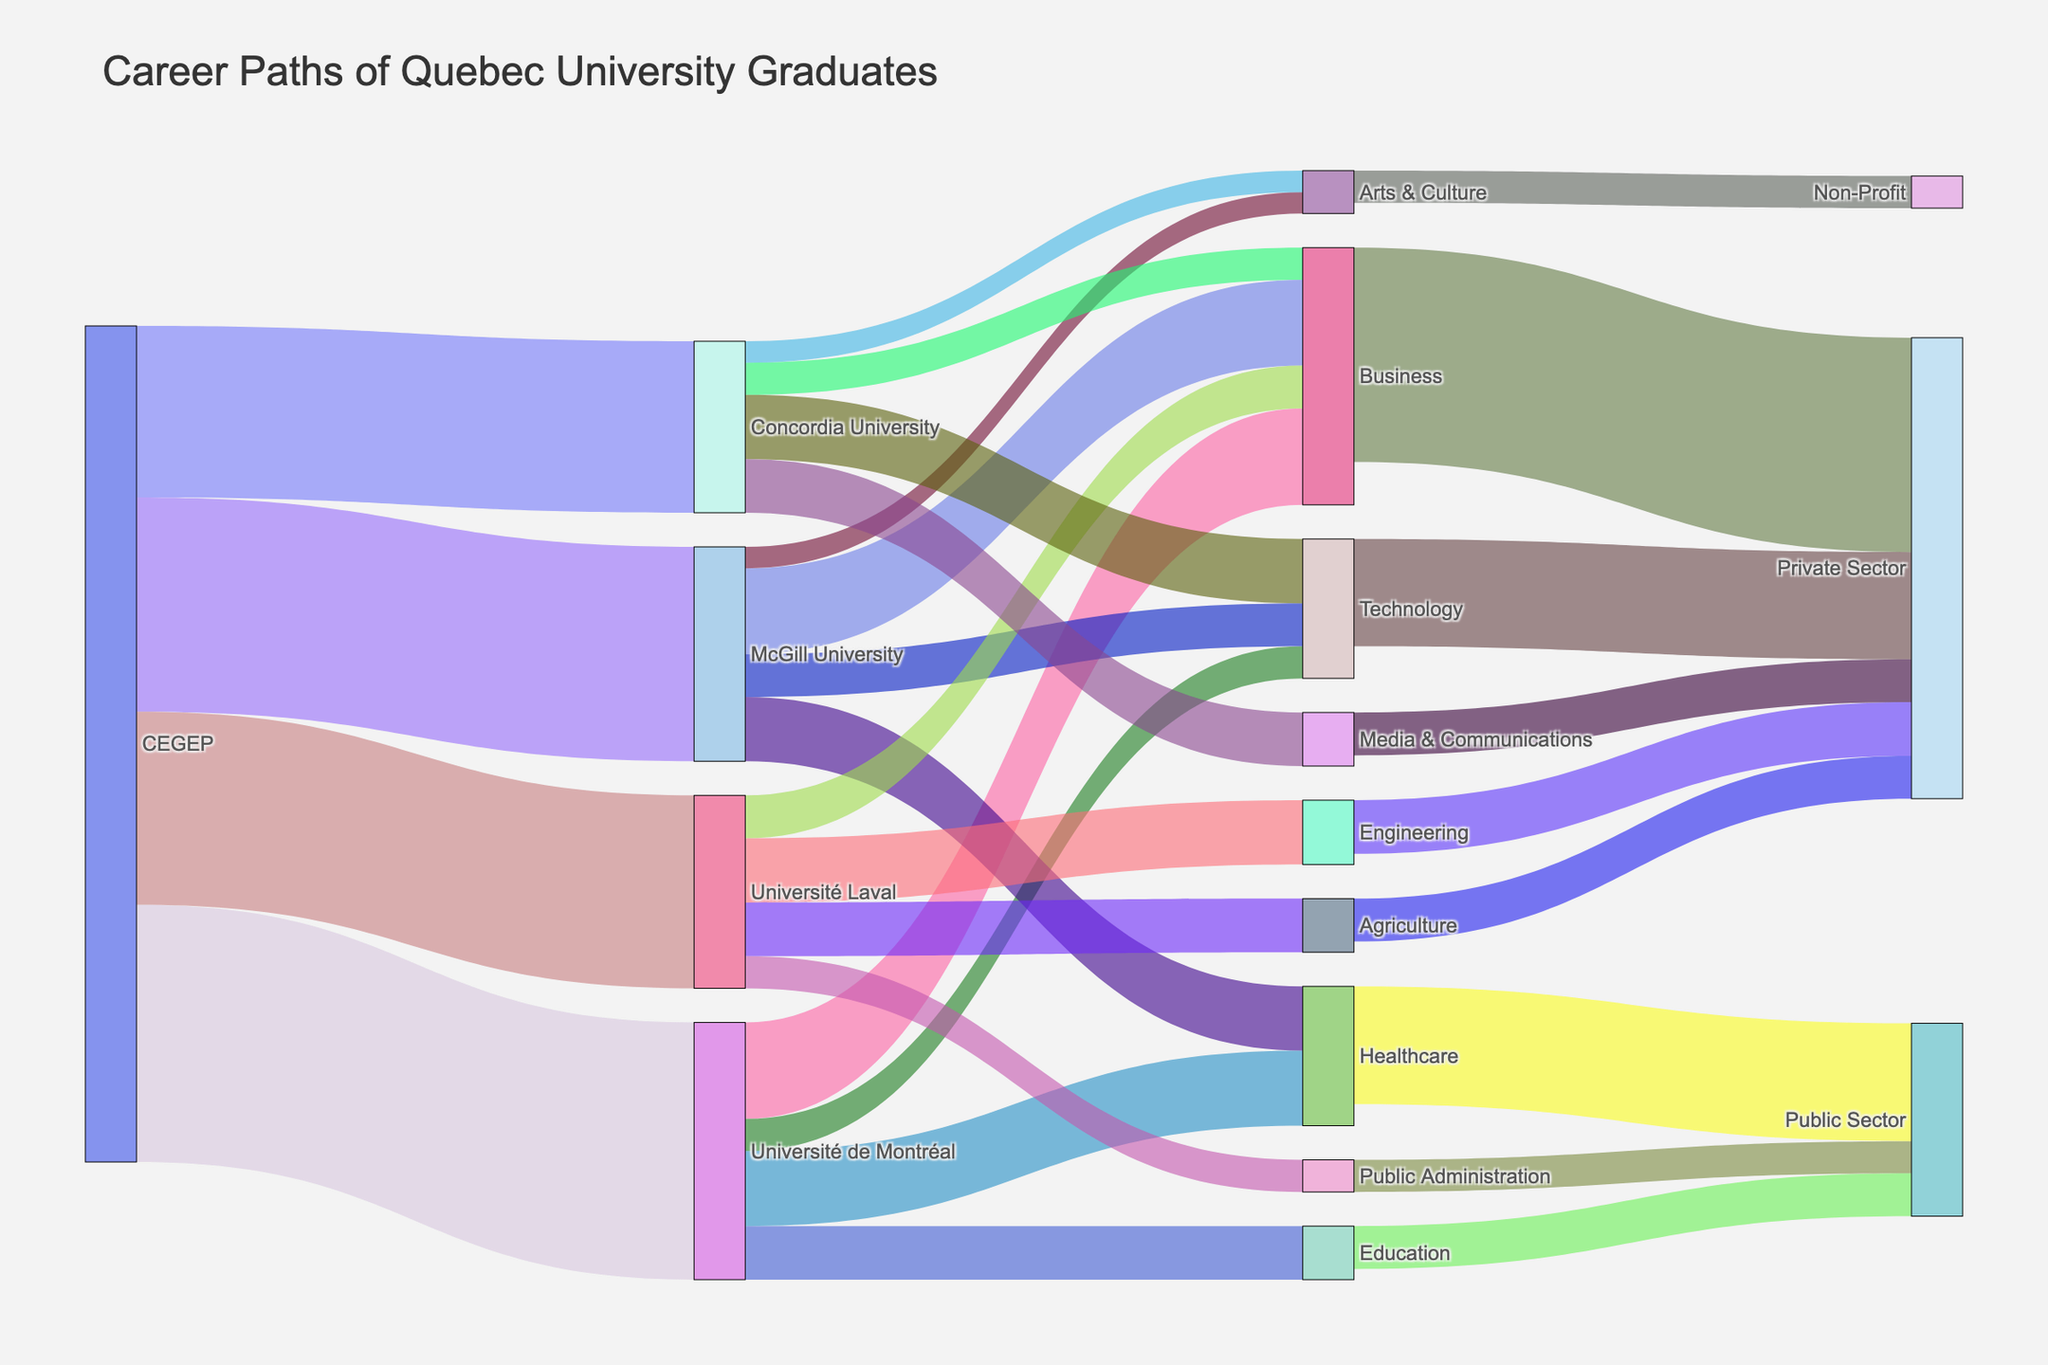what's the title of the figure? The title of the figure is shown prominently at the top.
Answer: Career Paths of Quebec University Graduates which university has the most graduates going into the business sector? Look for the university node with the highest value link leading to the Business target.
Answer: Université de Montréal how many graduates from Université Laval enter the Engineering sector? Find the link from Université Laval to Engineering and check its value.
Answer: 300 which sector has the least number of graduates from McGill University? Look at the values of links from McGill University and identify the one with the lowest value.
Answer: Arts & Culture what's the total number of graduates from CEGEP? Sum up the values of all the links originating from CEGEP. 1200 (Université de Montréal) + 1000 (McGill University) + 900 (Université Laval) + 800 (Concordia University) = 3900
Answer: 3900 how many graduates from Concordia University go into private sector jobs? Identify the relevant sectors (Technology, Media & Communications, Business) and sum their values: 300 (Technology) + 250 (Media & Communications) + 150 (Business) = 700.
Answer: 700 compare the number of graduates from Université de Montréal vs. McGill University going into the healthcare sector Identify the link values for both universities going into Healthcare: 350 (Université de Montréal) vs. 300 (McGill University).
Answer: Université de Montréal > McGill University how many graduates in total go into the public sector? Sum up all the links that end in Public Sector: 550 (Healthcare) + 200 (Education) + 150 (Public Administration) = 900.
Answer: 900 which university sends the most graduates into the technology sector? Examine the values of links from each university to the Technology sector and identify the largest value: Université de Montréal (150), McGill University (200), Concordia University (300).
Answer: Concordia University how many graduates from Université Laval go into non-private sector jobs? Sum up the values of links from Université Laval to non-private sectors: Agriculture (250) and Public Administration (150).
Answer: 400 